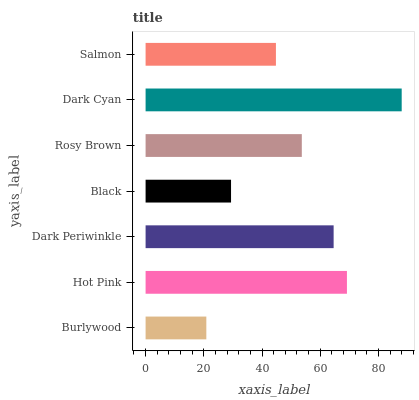Is Burlywood the minimum?
Answer yes or no. Yes. Is Dark Cyan the maximum?
Answer yes or no. Yes. Is Hot Pink the minimum?
Answer yes or no. No. Is Hot Pink the maximum?
Answer yes or no. No. Is Hot Pink greater than Burlywood?
Answer yes or no. Yes. Is Burlywood less than Hot Pink?
Answer yes or no. Yes. Is Burlywood greater than Hot Pink?
Answer yes or no. No. Is Hot Pink less than Burlywood?
Answer yes or no. No. Is Rosy Brown the high median?
Answer yes or no. Yes. Is Rosy Brown the low median?
Answer yes or no. Yes. Is Dark Periwinkle the high median?
Answer yes or no. No. Is Hot Pink the low median?
Answer yes or no. No. 